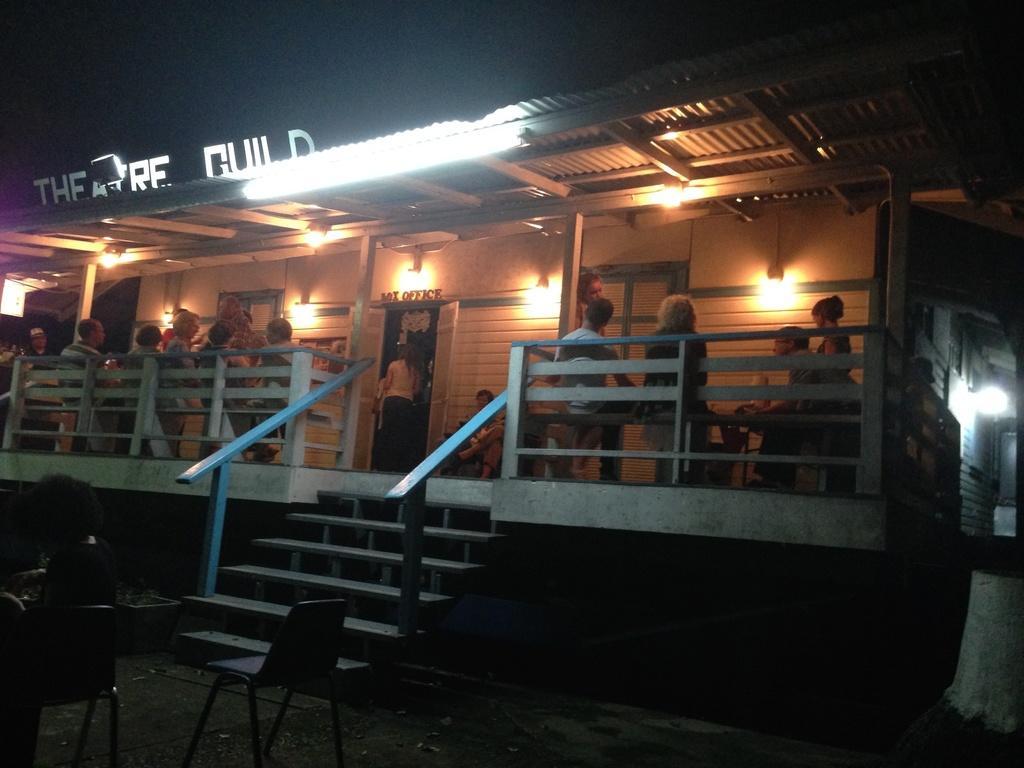In one or two sentences, can you explain what this image depicts? In this image, there are a few people. We can see some houses, lights. We can also see the shed and some text. We can see some stairs and the railing. We can also see the ground with some objects. We can also see some chairs. 